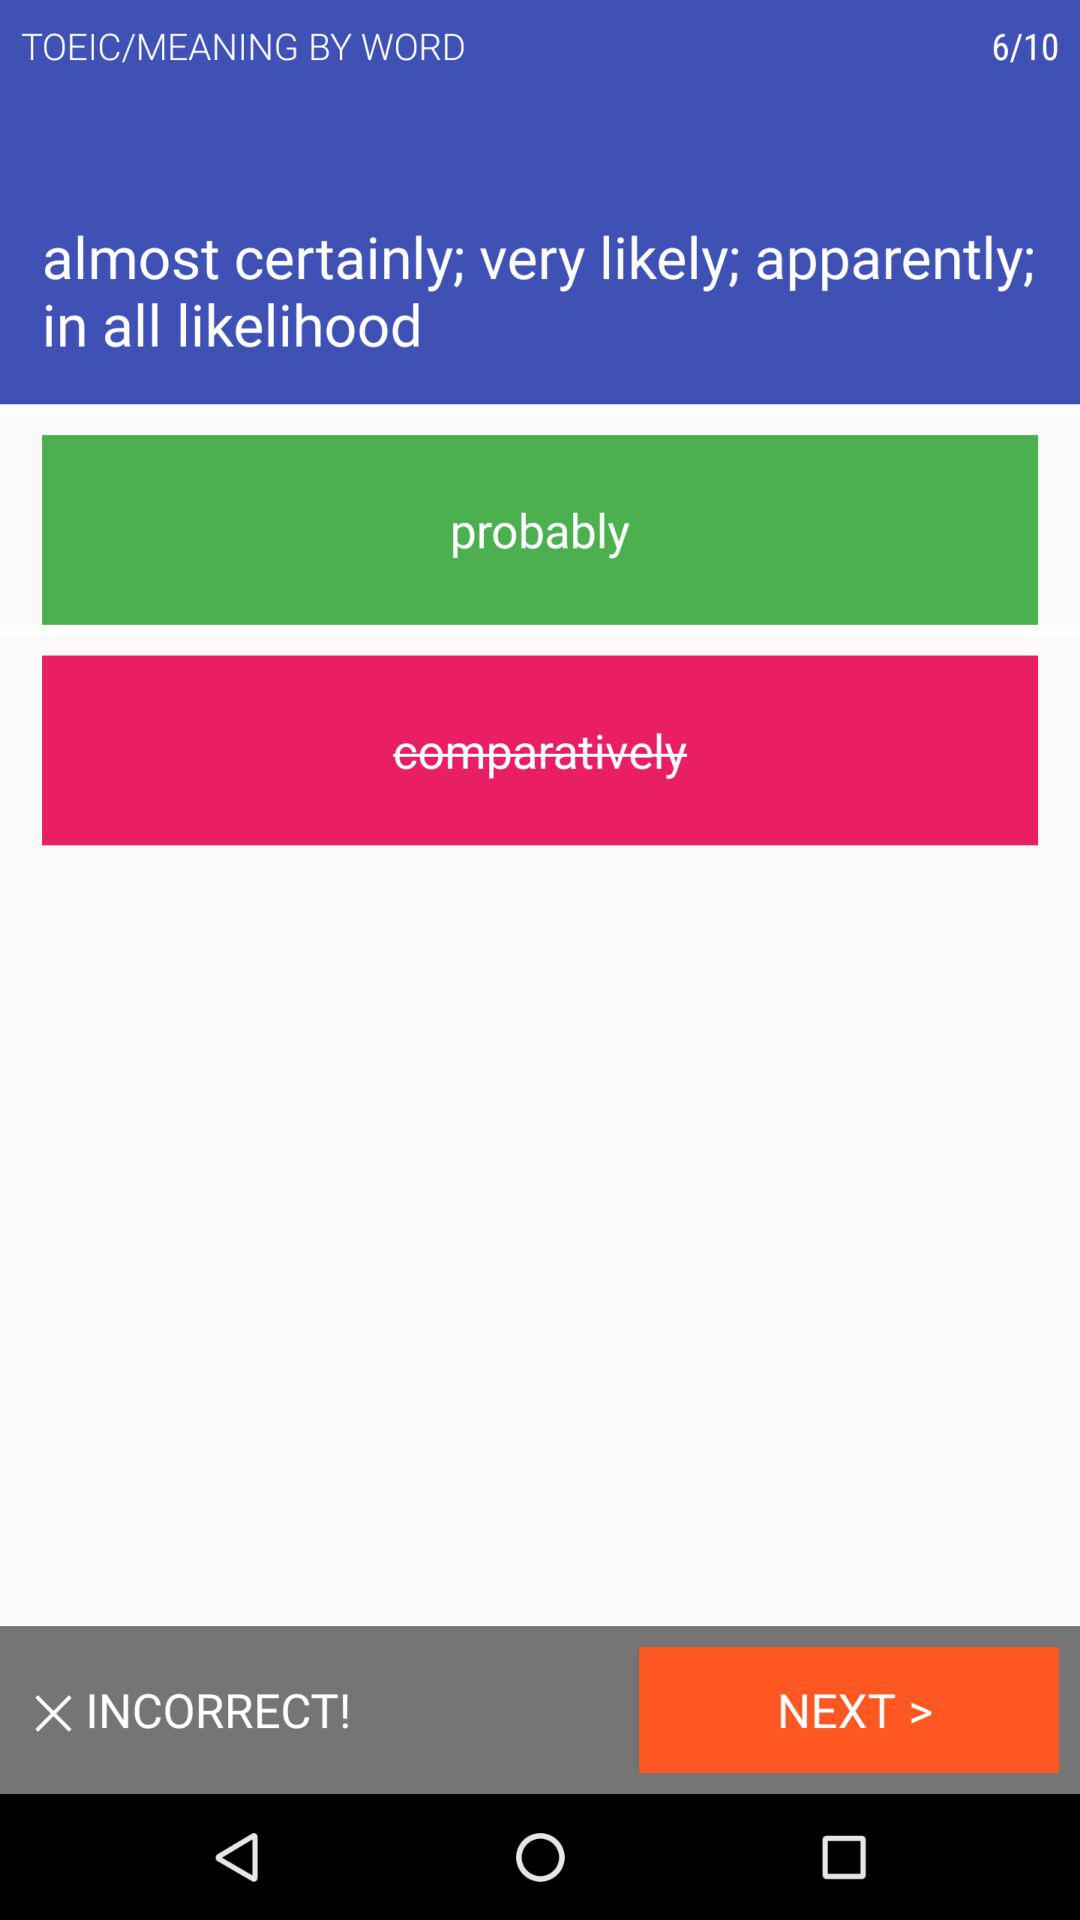What is the name of the application? The name of the application is "TOEIC". 